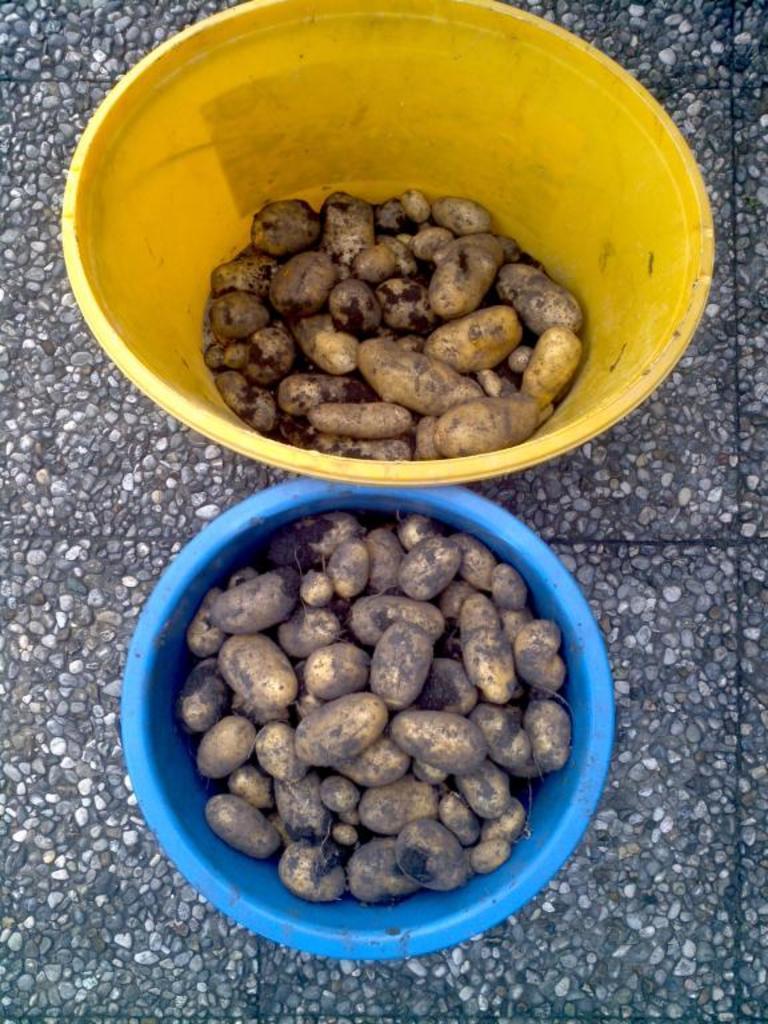Could you give a brief overview of what you see in this image? In this picture, we can see a few peanuts in two bowls, and we can see the ground. 